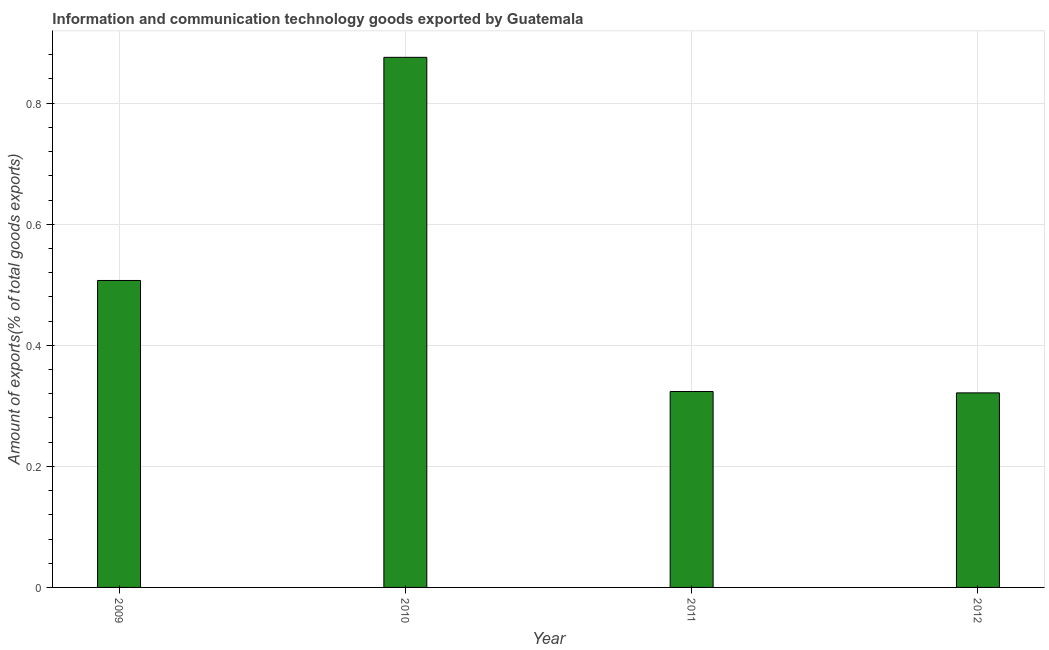Does the graph contain any zero values?
Keep it short and to the point. No. Does the graph contain grids?
Offer a very short reply. Yes. What is the title of the graph?
Make the answer very short. Information and communication technology goods exported by Guatemala. What is the label or title of the Y-axis?
Ensure brevity in your answer.  Amount of exports(% of total goods exports). What is the amount of ict goods exports in 2009?
Provide a short and direct response. 0.51. Across all years, what is the maximum amount of ict goods exports?
Offer a terse response. 0.88. Across all years, what is the minimum amount of ict goods exports?
Give a very brief answer. 0.32. What is the sum of the amount of ict goods exports?
Offer a terse response. 2.03. What is the difference between the amount of ict goods exports in 2011 and 2012?
Give a very brief answer. 0. What is the average amount of ict goods exports per year?
Your answer should be compact. 0.51. What is the median amount of ict goods exports?
Your response must be concise. 0.42. In how many years, is the amount of ict goods exports greater than 0.84 %?
Keep it short and to the point. 1. Do a majority of the years between 2011 and 2012 (inclusive) have amount of ict goods exports greater than 0.4 %?
Make the answer very short. No. What is the ratio of the amount of ict goods exports in 2009 to that in 2012?
Give a very brief answer. 1.58. Is the amount of ict goods exports in 2009 less than that in 2012?
Provide a succinct answer. No. Is the difference between the amount of ict goods exports in 2009 and 2012 greater than the difference between any two years?
Ensure brevity in your answer.  No. What is the difference between the highest and the second highest amount of ict goods exports?
Provide a succinct answer. 0.37. Is the sum of the amount of ict goods exports in 2010 and 2012 greater than the maximum amount of ict goods exports across all years?
Provide a succinct answer. Yes. What is the difference between the highest and the lowest amount of ict goods exports?
Ensure brevity in your answer.  0.55. How many bars are there?
Offer a terse response. 4. Are all the bars in the graph horizontal?
Provide a short and direct response. No. What is the difference between two consecutive major ticks on the Y-axis?
Make the answer very short. 0.2. What is the Amount of exports(% of total goods exports) in 2009?
Offer a very short reply. 0.51. What is the Amount of exports(% of total goods exports) in 2010?
Make the answer very short. 0.88. What is the Amount of exports(% of total goods exports) in 2011?
Provide a succinct answer. 0.32. What is the Amount of exports(% of total goods exports) of 2012?
Offer a terse response. 0.32. What is the difference between the Amount of exports(% of total goods exports) in 2009 and 2010?
Offer a very short reply. -0.37. What is the difference between the Amount of exports(% of total goods exports) in 2009 and 2011?
Provide a short and direct response. 0.18. What is the difference between the Amount of exports(% of total goods exports) in 2009 and 2012?
Give a very brief answer. 0.19. What is the difference between the Amount of exports(% of total goods exports) in 2010 and 2011?
Give a very brief answer. 0.55. What is the difference between the Amount of exports(% of total goods exports) in 2010 and 2012?
Your response must be concise. 0.55. What is the difference between the Amount of exports(% of total goods exports) in 2011 and 2012?
Provide a short and direct response. 0. What is the ratio of the Amount of exports(% of total goods exports) in 2009 to that in 2010?
Provide a short and direct response. 0.58. What is the ratio of the Amount of exports(% of total goods exports) in 2009 to that in 2011?
Offer a terse response. 1.57. What is the ratio of the Amount of exports(% of total goods exports) in 2009 to that in 2012?
Your response must be concise. 1.58. What is the ratio of the Amount of exports(% of total goods exports) in 2010 to that in 2011?
Your answer should be very brief. 2.71. What is the ratio of the Amount of exports(% of total goods exports) in 2010 to that in 2012?
Ensure brevity in your answer.  2.73. What is the ratio of the Amount of exports(% of total goods exports) in 2011 to that in 2012?
Your answer should be very brief. 1.01. 